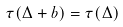<formula> <loc_0><loc_0><loc_500><loc_500>\tau ( \Delta + b ) = \tau ( \Delta )</formula> 